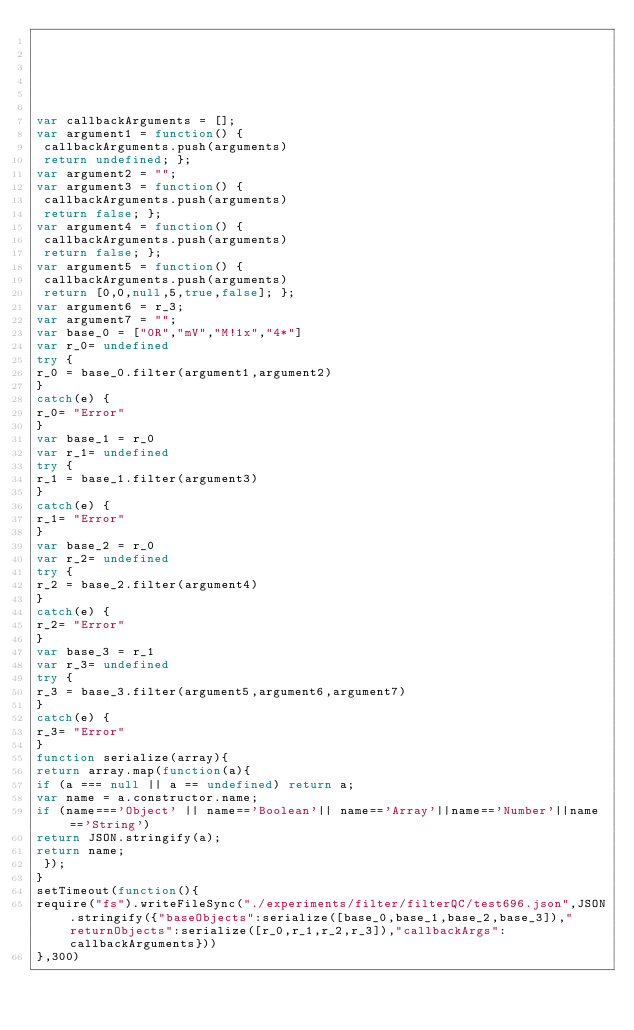Convert code to text. <code><loc_0><loc_0><loc_500><loc_500><_JavaScript_>





var callbackArguments = [];
var argument1 = function() {
 callbackArguments.push(arguments) 
 return undefined; };
var argument2 = "";
var argument3 = function() {
 callbackArguments.push(arguments) 
 return false; };
var argument4 = function() {
 callbackArguments.push(arguments) 
 return false; };
var argument5 = function() {
 callbackArguments.push(arguments) 
 return [0,0,null,5,true,false]; };
var argument6 = r_3;
var argument7 = "";
var base_0 = ["0R","mV","M!1x","4*"]
var r_0= undefined
try {
r_0 = base_0.filter(argument1,argument2)
}
catch(e) {
r_0= "Error"
}
var base_1 = r_0
var r_1= undefined
try {
r_1 = base_1.filter(argument3)
}
catch(e) {
r_1= "Error"
}
var base_2 = r_0
var r_2= undefined
try {
r_2 = base_2.filter(argument4)
}
catch(e) {
r_2= "Error"
}
var base_3 = r_1
var r_3= undefined
try {
r_3 = base_3.filter(argument5,argument6,argument7)
}
catch(e) {
r_3= "Error"
}
function serialize(array){
return array.map(function(a){
if (a === null || a == undefined) return a;
var name = a.constructor.name;
if (name==='Object' || name=='Boolean'|| name=='Array'||name=='Number'||name=='String')
return JSON.stringify(a);
return name;
 });
}
setTimeout(function(){
require("fs").writeFileSync("./experiments/filter/filterQC/test696.json",JSON.stringify({"baseObjects":serialize([base_0,base_1,base_2,base_3]),"returnObjects":serialize([r_0,r_1,r_2,r_3]),"callbackArgs":callbackArguments}))
},300)</code> 